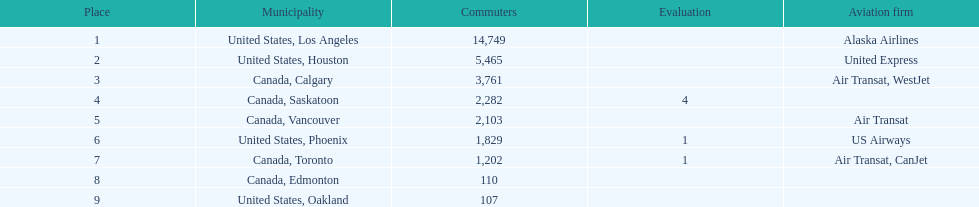The least number of passengers came from which city United States, Oakland. 